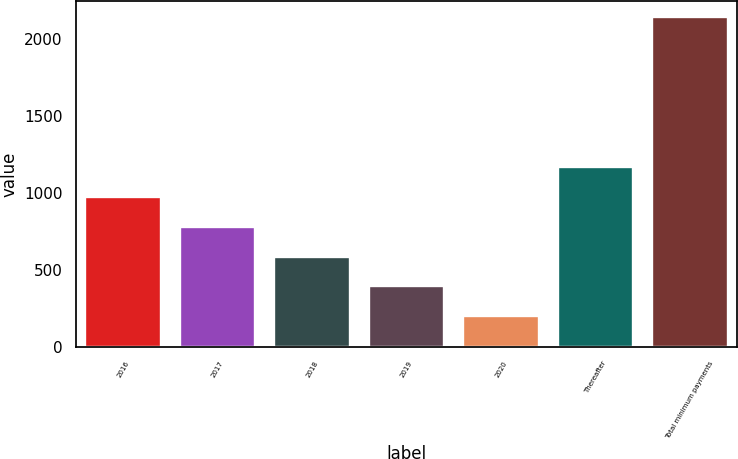Convert chart to OTSL. <chart><loc_0><loc_0><loc_500><loc_500><bar_chart><fcel>2016<fcel>2017<fcel>2018<fcel>2019<fcel>2020<fcel>Thereafter<fcel>Total minimum payments<nl><fcel>977.4<fcel>782.8<fcel>588.2<fcel>393.6<fcel>199<fcel>1172<fcel>2145<nl></chart> 